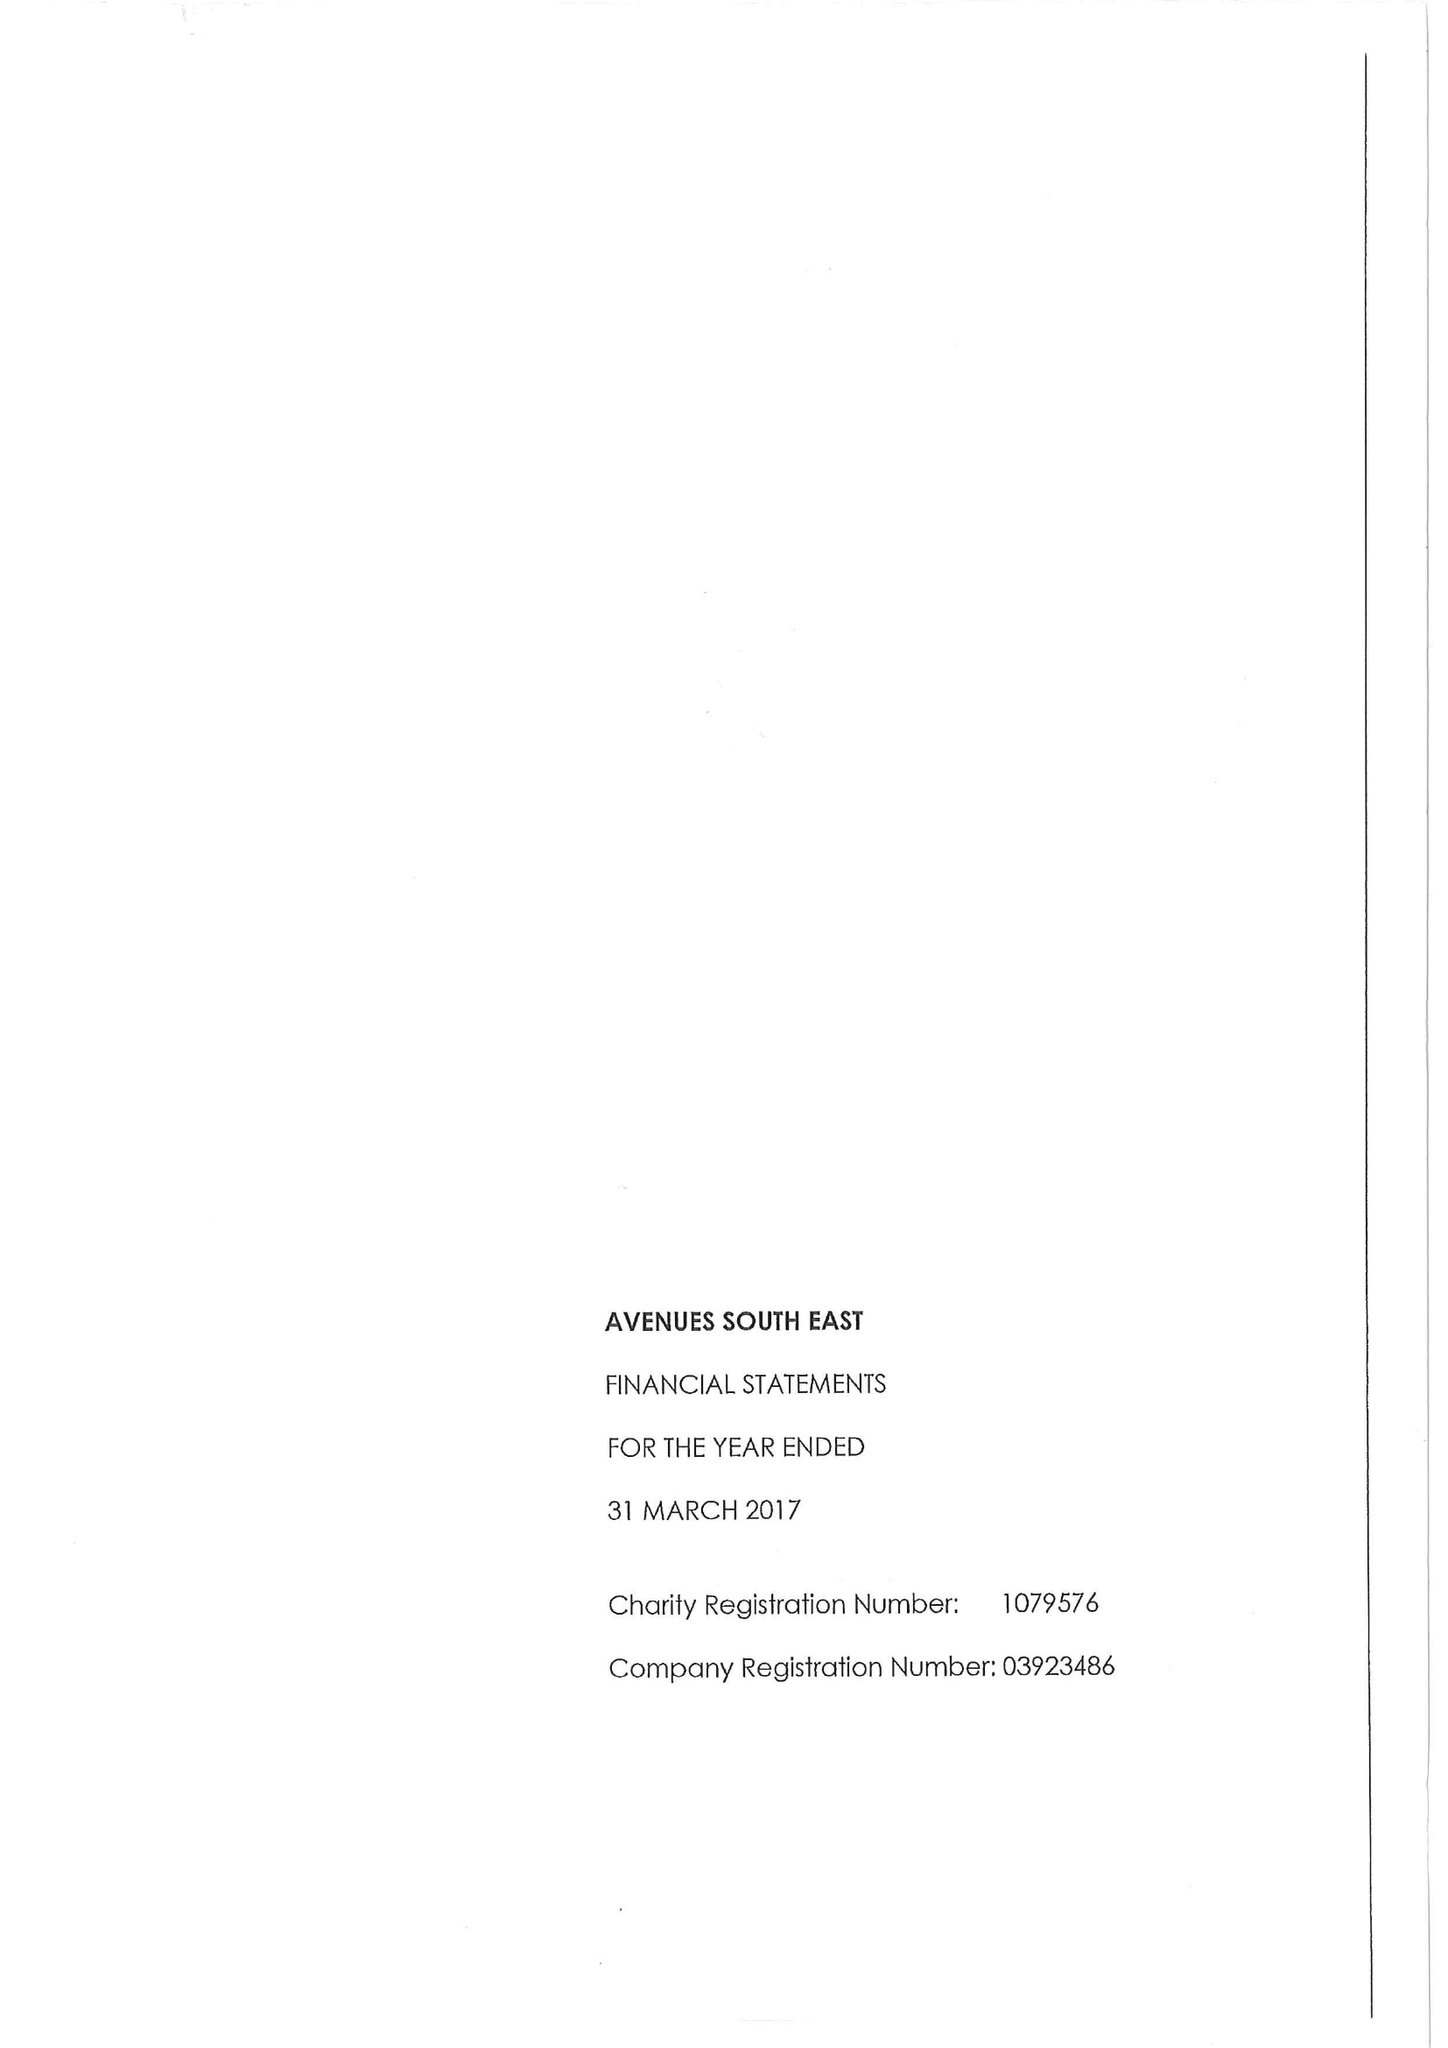What is the value for the income_annually_in_british_pounds?
Answer the question using a single word or phrase. 15231000.00 